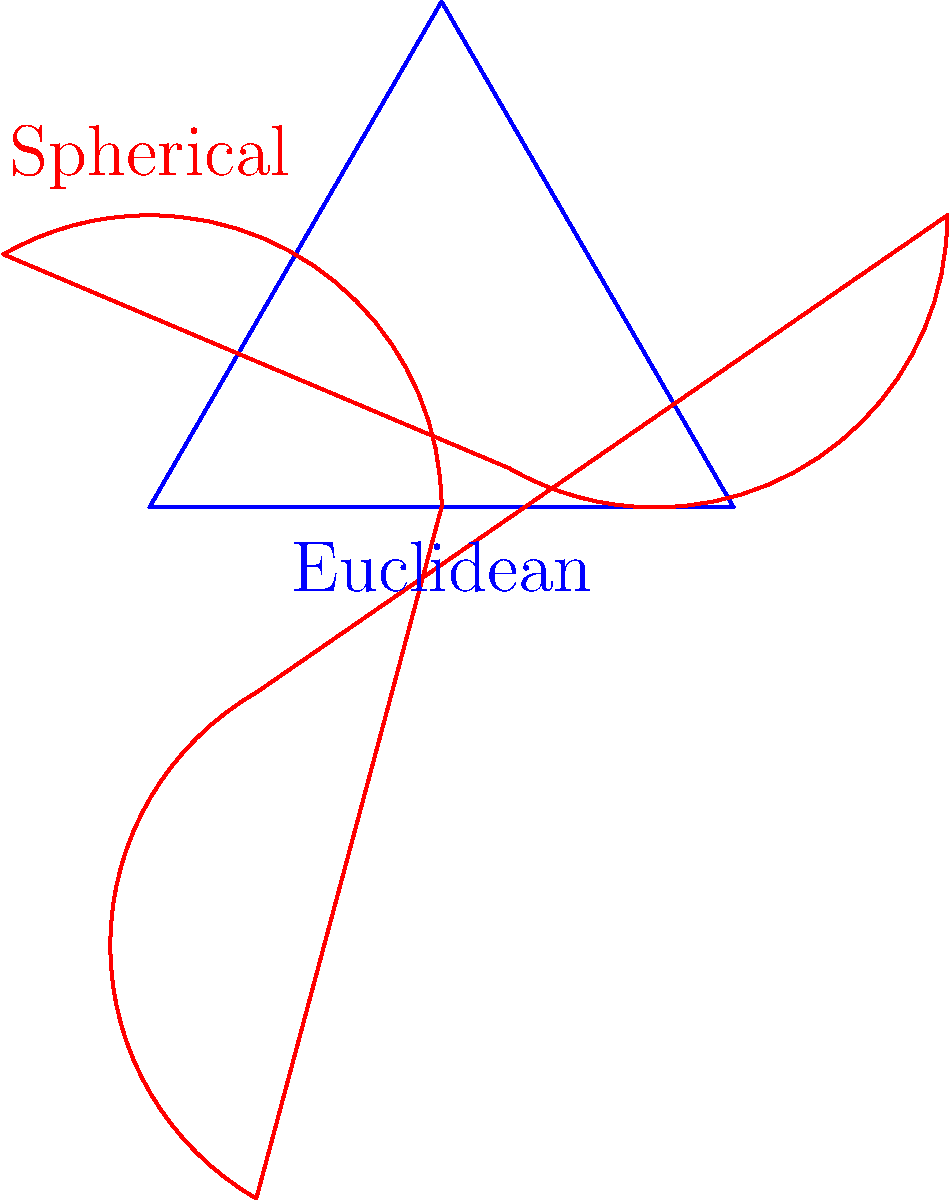In light of recent political decisions affecting funding for geometric research, you're writing an article on the fundamental differences between Euclidean and non-Euclidean geometries. How do the angle sums of triangles differ in Euclidean, spherical, and hyperbolic geometries, and what implications might this have for our understanding of space? To understand the differences in triangle angle sums across geometries:

1. Euclidean geometry:
   - In a flat plane, the sum of angles in a triangle is always 180°.
   - This is a fundamental property of Euclidean space.

2. Spherical geometry (positive curvature):
   - On a sphere's surface, the sum of angles in a triangle is always > 180°.
   - As triangle size increases, so does the angle sum.
   - The excess over 180° is proportional to the triangle's area.

3. Hyperbolic geometry (negative curvature):
   - In hyperbolic space, the sum of angles in a triangle is always < 180°.
   - As triangle size increases, the angle sum decreases.
   - The deficiency below 180° is proportional to the triangle's area.

These differences arise from the curvature of space:
- Euclidean space has zero curvature.
- Spherical space has positive curvature.
- Hyperbolic space has negative curvature.

Implications for understanding space:
- These geometries challenge our intuitive understanding of space.
- They suggest that the nature of space itself might be non-Euclidean.
- This has profound implications for cosmology and our understanding of the universe's shape.

In the context of political decisions affecting research funding, understanding these fundamental geometric differences is crucial for advancing our knowledge of the universe's structure and supporting critical fields like astrophysics and cosmology.
Answer: Euclidean: 180°; Spherical: > 180°; Hyperbolic: < 180°. Implies space may be non-Euclidean, impacting cosmology. 